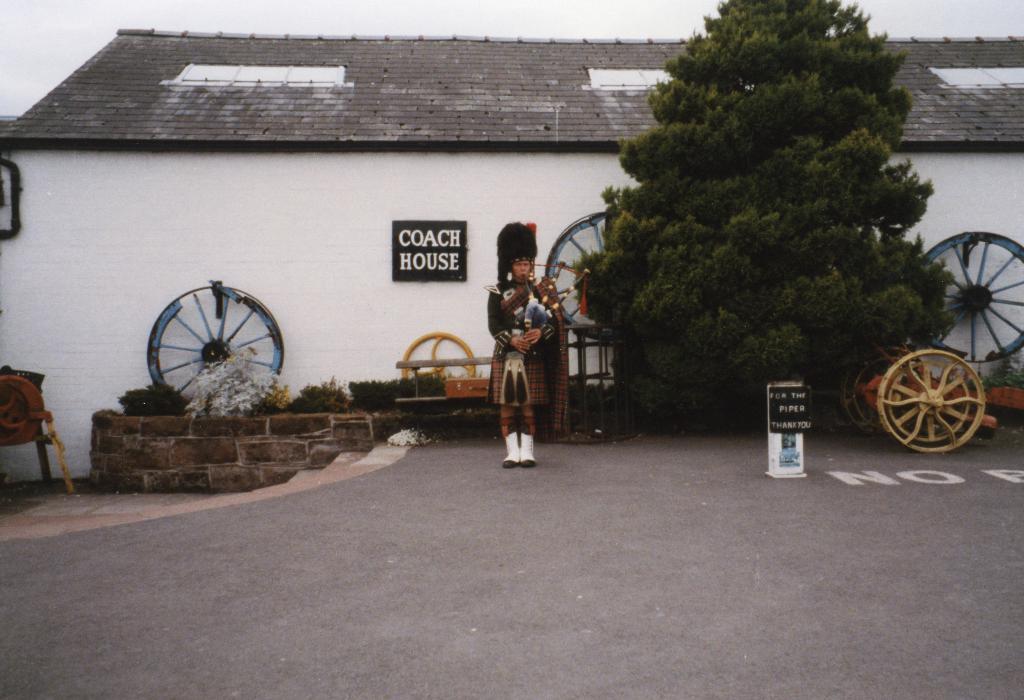Can you describe this image briefly? In this image, in the middle, we can see a person standing, we can see some wheels, there is a white wall, we can see a black color board on the wall. We can see the roof and the sky. 